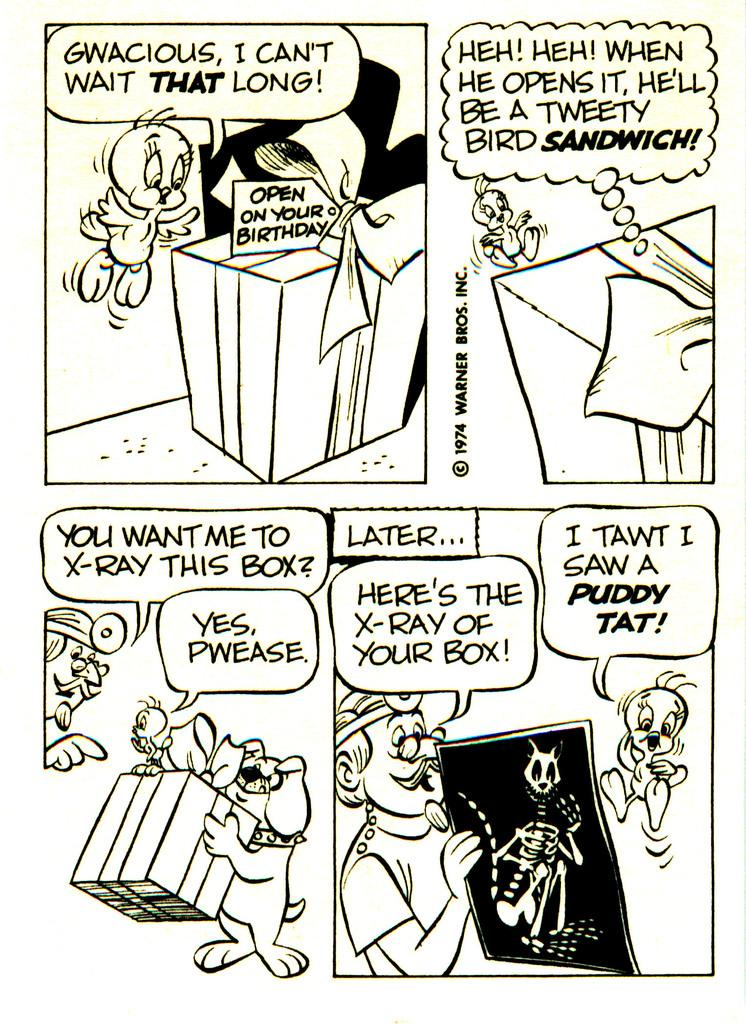What type of artwork is depicted in the image? There are animated paintings of a person, a dog, food, and a table in the image. What other elements can be seen in the animated paintings? The animated paintings depict a person, a dog, food, and a table. Is there any text present in the image? Yes, there is text present in the image. What type of canvas is used for the animated paintings in the image? The image does not provide information about the canvas used for the animated paintings. Is there a church depicted in the animated paintings in the image? There is no mention of a church in the provided facts, and no church is depicted in the animated paintings. 